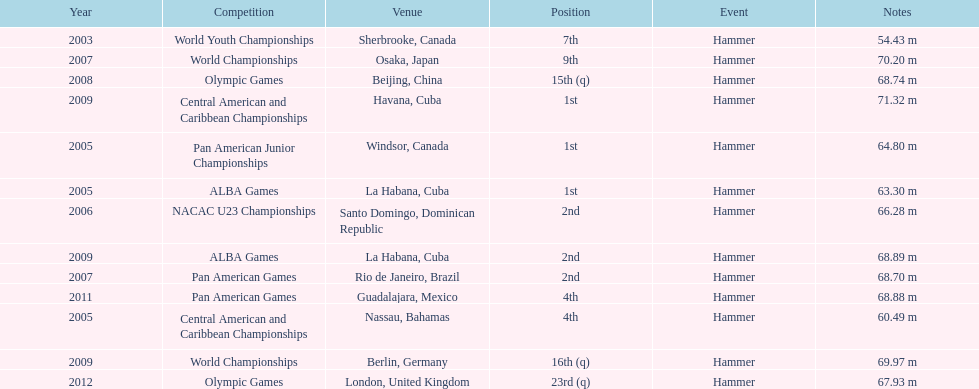Does arasay thondike have more/less than 4 1st place tournament finishes? Less. 